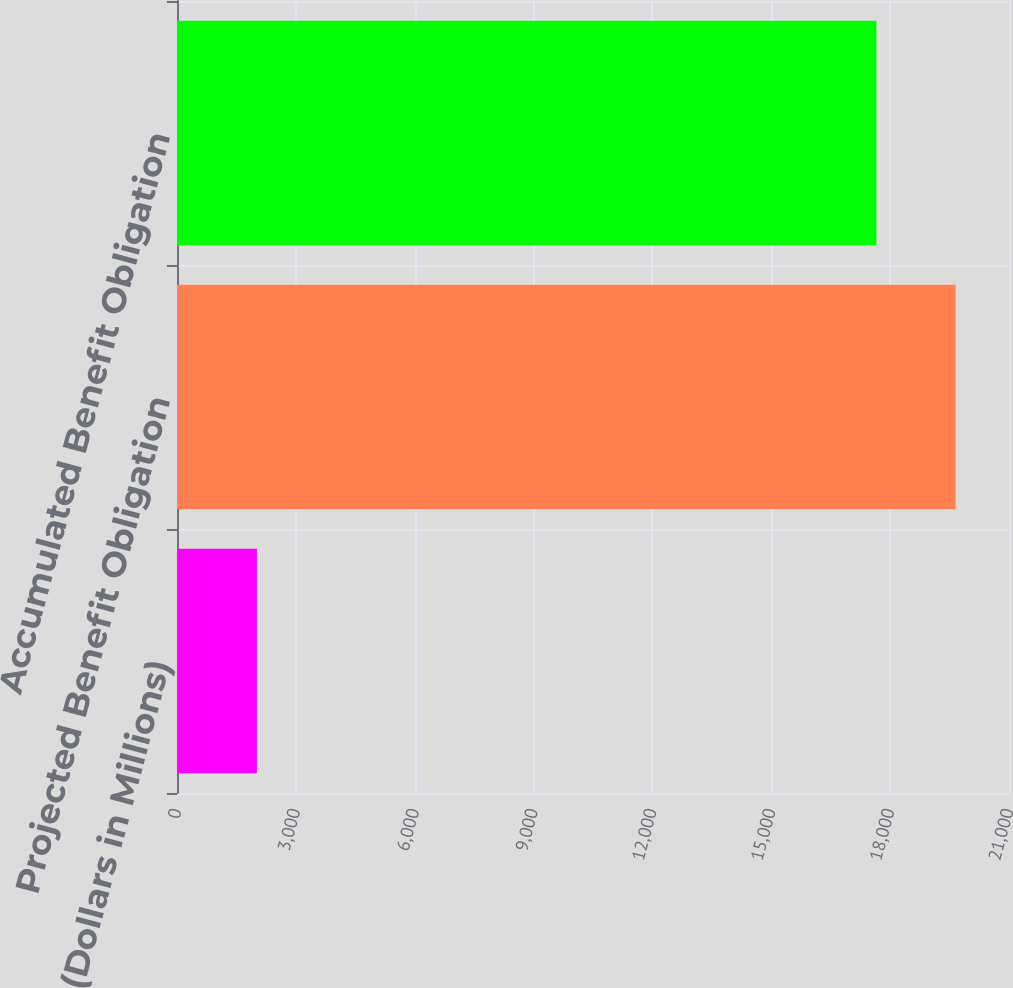<chart> <loc_0><loc_0><loc_500><loc_500><bar_chart><fcel>(Dollars in Millions)<fcel>Projected Benefit Obligation<fcel>Accumulated Benefit Obligation<nl><fcel>2017<fcel>19652<fcel>17654<nl></chart> 